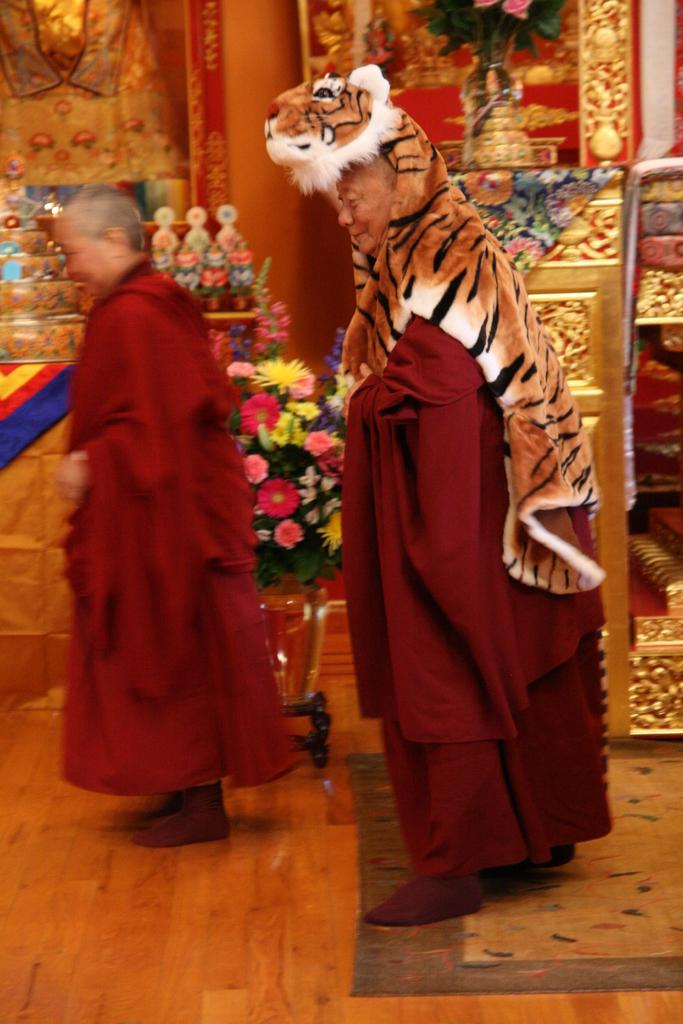Who is the main subject in the center of the image? There is a man standing in the center of the image. Can you describe the person on the left side of the image? There is a person standing on the left side of the image. What can be seen in the background of the image? There are flower vases, flowers, and gods idols in the background of the image. What type of pain is the tiger experiencing in the image? There is no tiger present in the image, so it is not possible to determine if a tiger is experiencing any pain. 